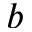Convert formula to latex. <formula><loc_0><loc_0><loc_500><loc_500>b</formula> 